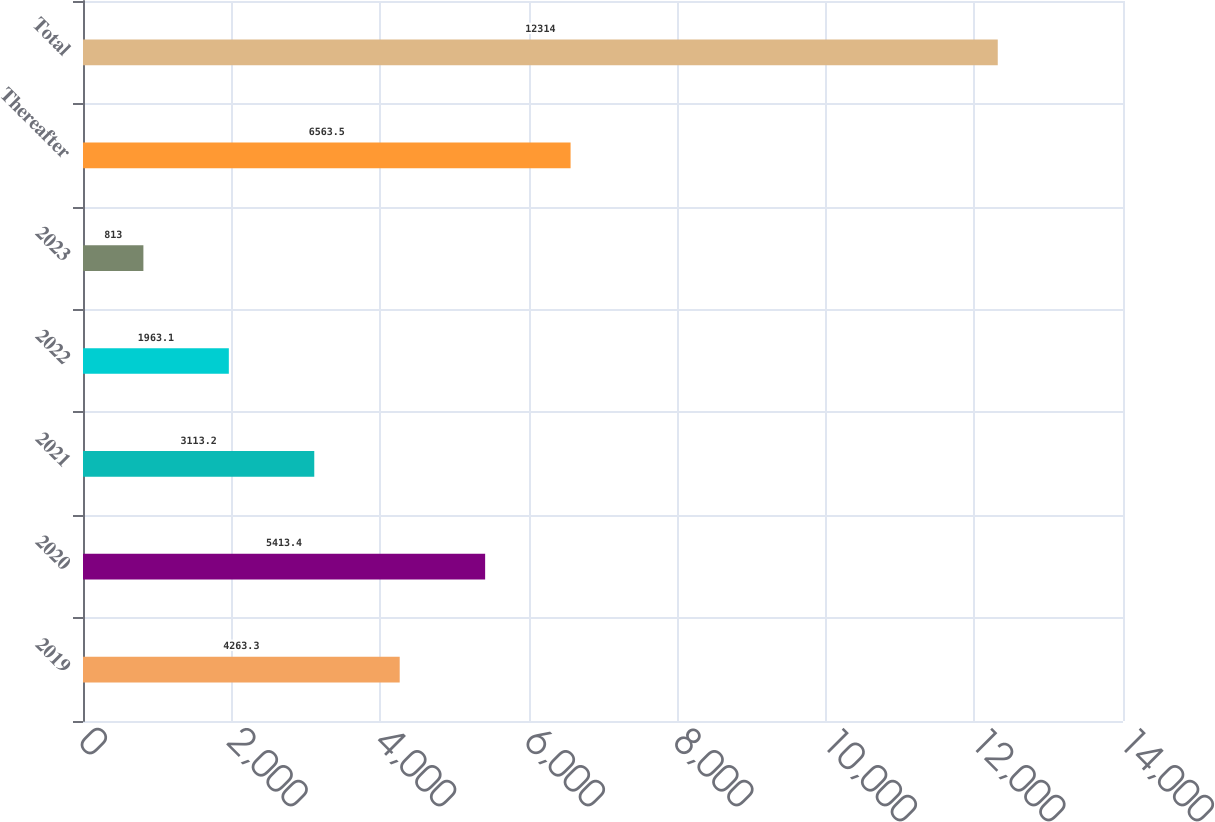<chart> <loc_0><loc_0><loc_500><loc_500><bar_chart><fcel>2019<fcel>2020<fcel>2021<fcel>2022<fcel>2023<fcel>Thereafter<fcel>Total<nl><fcel>4263.3<fcel>5413.4<fcel>3113.2<fcel>1963.1<fcel>813<fcel>6563.5<fcel>12314<nl></chart> 